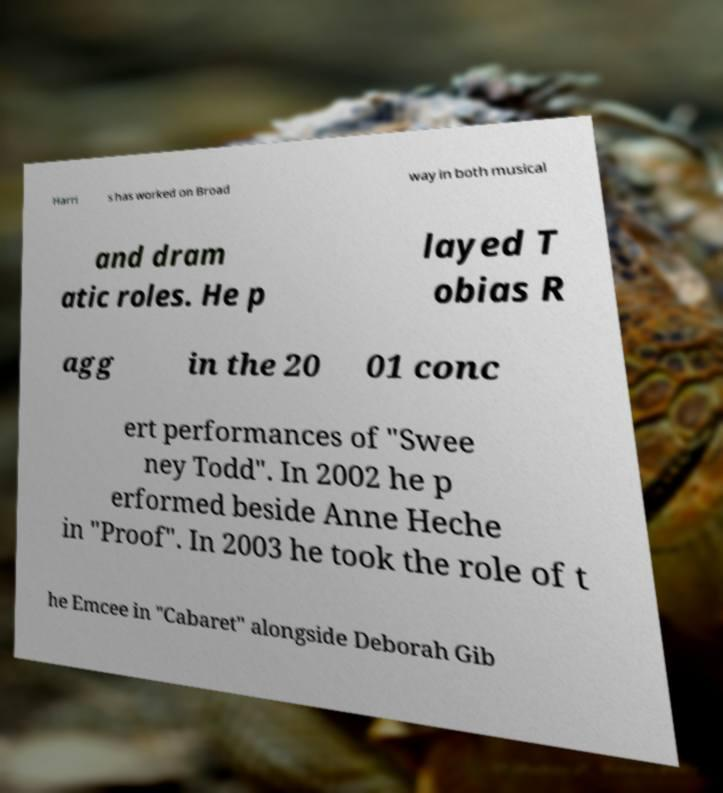What messages or text are displayed in this image? I need them in a readable, typed format. Harri s has worked on Broad way in both musical and dram atic roles. He p layed T obias R agg in the 20 01 conc ert performances of "Swee ney Todd". In 2002 he p erformed beside Anne Heche in "Proof". In 2003 he took the role of t he Emcee in "Cabaret" alongside Deborah Gib 